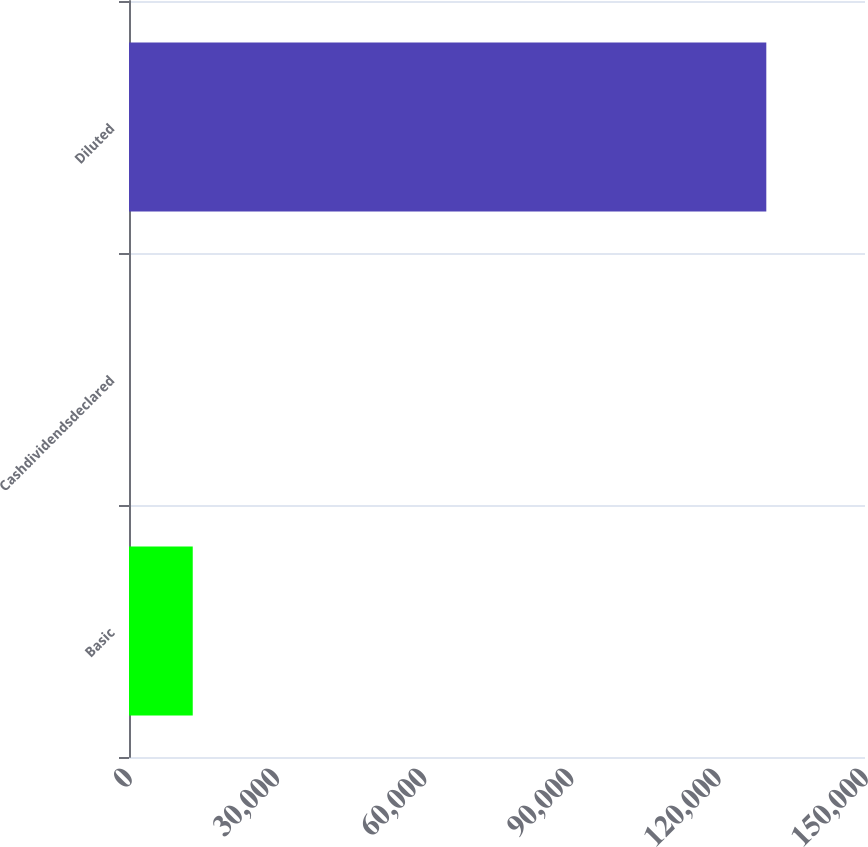Convert chart. <chart><loc_0><loc_0><loc_500><loc_500><bar_chart><fcel>Basic<fcel>Cashdividendsdeclared<fcel>Diluted<nl><fcel>12990.1<fcel>1.72<fcel>129886<nl></chart> 